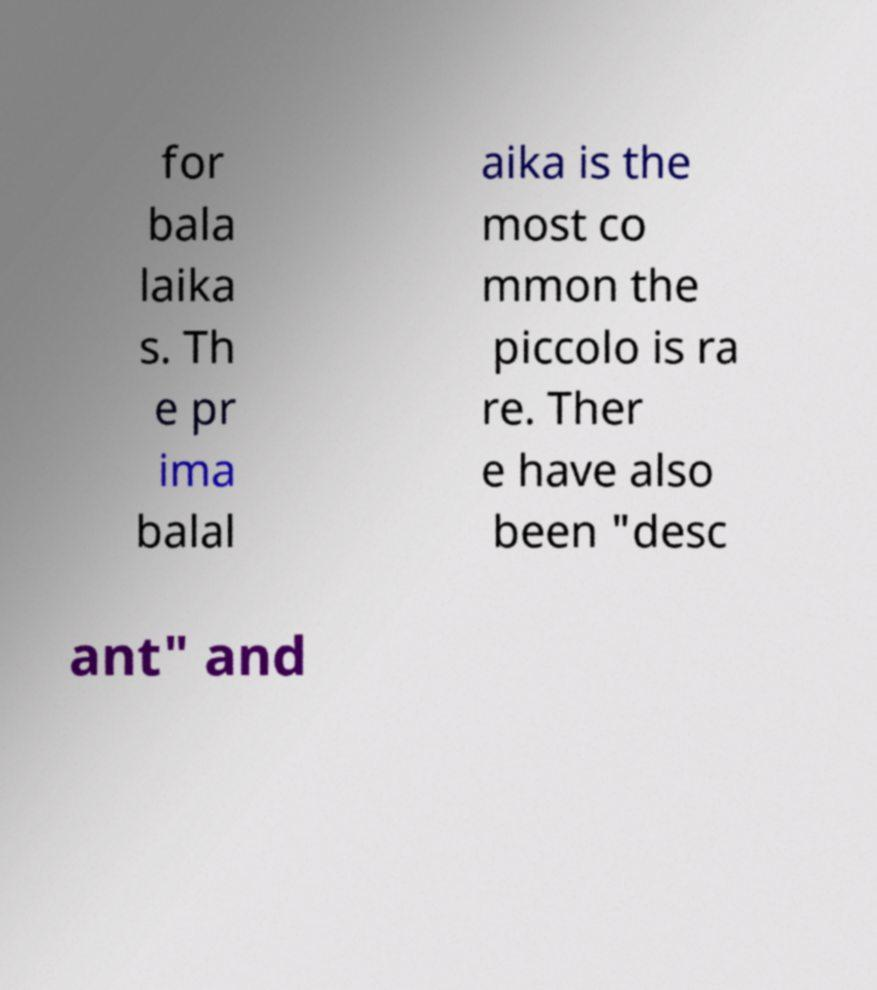What messages or text are displayed in this image? I need them in a readable, typed format. for bala laika s. Th e pr ima balal aika is the most co mmon the piccolo is ra re. Ther e have also been "desc ant" and 